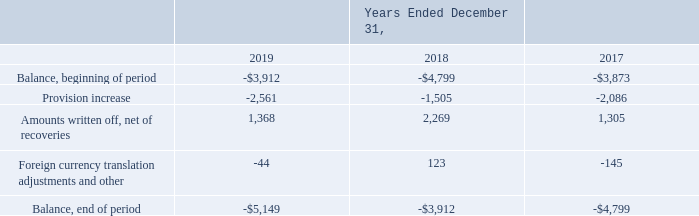The Company maintains a general allowance for doubtful accounts based on historical experience, along with additional customer specific allowances. The Company regularly monitors credit risk exposures in consolidated receivables. In estimating the necessary level of our allowance for doubtful accounts, management considers the aging of accounts receivable, the creditworthiness of customers, economic conditions within the customer’s industry, and general economic conditions, among other factors.
The following reflects activity in the Company’s allowance for doubtful accounts receivable for the periods indicated (in thousands):
Provision increases recorded in general and administrative expense during the years ended December 31, 2019, 2018, and 2017, reflect increases in the allowance for doubtful accounts based upon collection experience in the geographic regions in which the Company conducts business, net of collection of customer-specific receivables that were previously reserved for as doubtful of collection.
What does the company consider in estimating the necessary level of allowance for doubtful accounts? The aging of accounts receivable, the creditworthiness of customers, economic conditions within the customer’s industry, and general economic conditions, among other factors. What was the balance at the end of period in 2019?
Answer scale should be: thousand. -$5,149. What was the balance at the end of period in 2018?
Answer scale should be: thousand. -$3,912. What was the change in balance at the end of period between 2018 and 2019?
Answer scale should be: thousand. -$5,149+3,912
Answer: -1237. What was the change in Amounts written off, net of recoveries between 2018 and 2019?
Answer scale should be: thousand. 1,368-2,269
Answer: -901. What was the percentage change in Amounts written off, net of recoveries between 2017 and 2018?
Answer scale should be: percent. (2,269-1,305)/1,305
Answer: 73.87. 